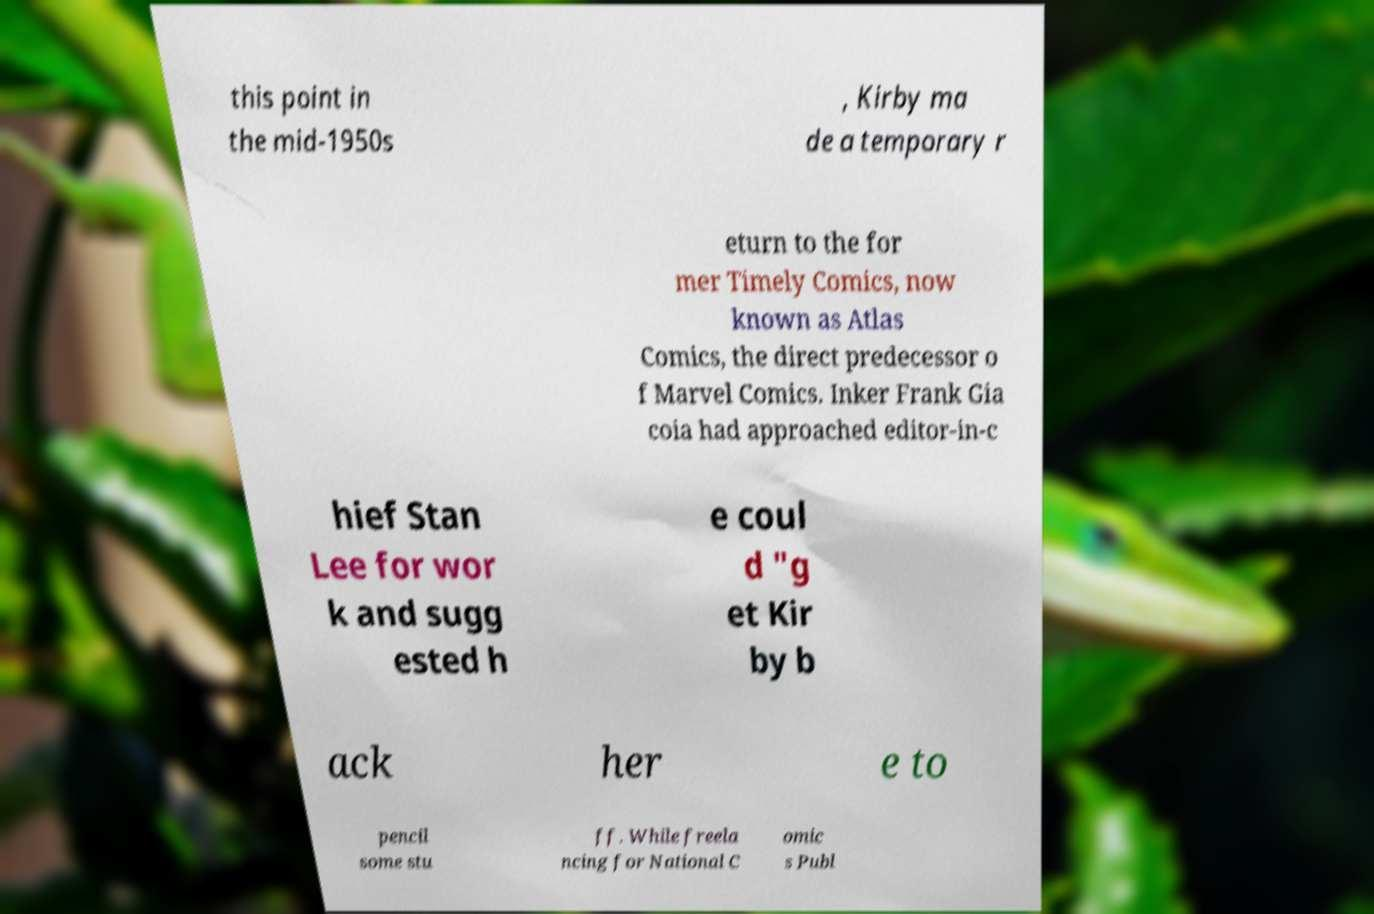There's text embedded in this image that I need extracted. Can you transcribe it verbatim? this point in the mid-1950s , Kirby ma de a temporary r eturn to the for mer Timely Comics, now known as Atlas Comics, the direct predecessor o f Marvel Comics. Inker Frank Gia coia had approached editor-in-c hief Stan Lee for wor k and sugg ested h e coul d "g et Kir by b ack her e to pencil some stu ff. While freela ncing for National C omic s Publ 